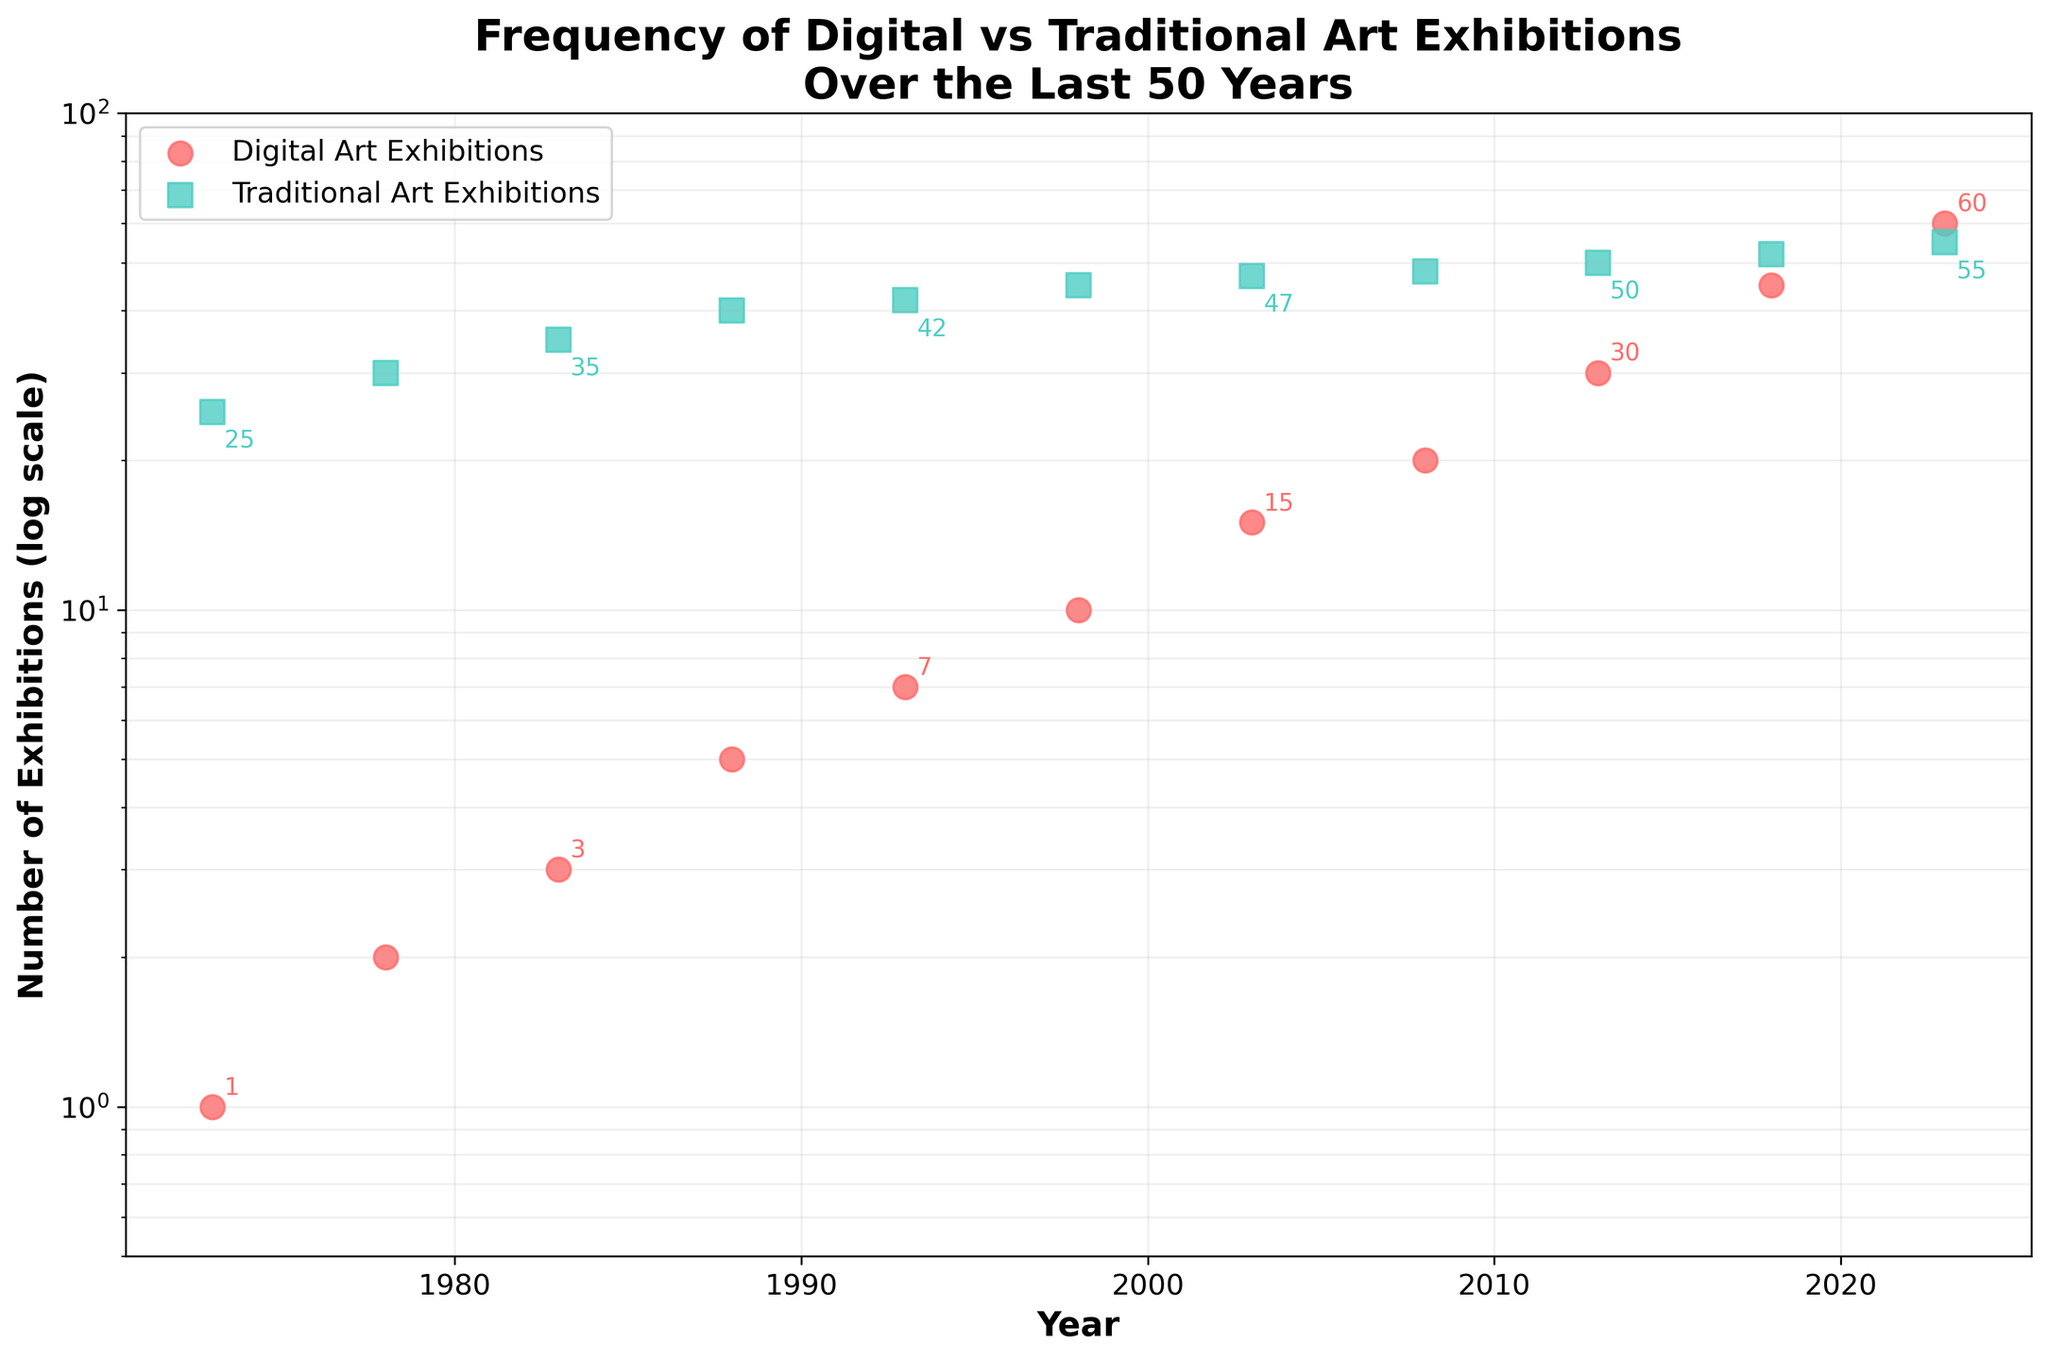How are the Digital Art Exhibitions and Traditional Art Exhibitions labeled in the scatter plot? The legend on the upper left of the plot indicates that the red circles represent Digital Art Exhibitions, and the green squares represent Traditional Art Exhibitions.
Answer: Red circles for Digital, green squares for Traditional What is the title of the scatter plot? The title is located at the top of the figure and reads "Frequency of Digital vs Traditional Art Exhibitions Over the Last 50 Years."
Answer: Frequency of Digital vs Traditional Art Exhibitions Over the Last 50 Years How many years are represented in the scatter plot? By counting the number of data points along the horizontal axis, we can see that there are 11 years represented from 1973 to 2023.
Answer: 11 years What year saw the first increase in Digital Art Exhibitions compared to the previous data point? Observing the red circles along the years, the first increase is from 1973 to 1978, where the number of exhibitions increases from 1 to 2.
Answer: 1978 By how much did Digital Art Exhibitions increase from 2013 to 2018? The number of Digital Art Exhibitions in 2013 is 30, and in 2018 it is 45. The difference is 45 - 30.
Answer: 15 In which year are the numbers of Digital and Traditional Art Exhibitions closest to each other? In 2023, the number of Digital Art Exhibitions is 60 and Traditional Art Exhibitions is 55. This is the closest gap in comparison to other years.
Answer: 2023 Which type of art exhibitions experienced a greater increase between 2003 and 2013? From 2003 to 2013, Digital Art Exhibitions increased from 15 to 30, while Traditional Art Exhibitions increased from 47 to 50. The increase for Digital Art is greater (15 vs. 3).
Answer: Digital Art Exhibitions On a log scale, which year had the steepest increase in Digital Art Exhibitions? The plot shows the interval from 2008 to 2013 has a visible steep increase from 20 to 30 on the log scale.
Answer: 2008 to 2013 What is the general trend observed for Digital Art Exhibitions over the last 50 years? The general trend shows a consistent and accelerating increase in the number of Digital Art Exhibitions over time.
Answer: Increasing Are Traditional Art Exhibitions consistently increasing over the years? Observing the green squares over the years, Traditional Art Exhibitions show a slight increase, but the growth is much slower and more stable compared to Digital Art Exhibitions.
Answer: Slow and stable increase 